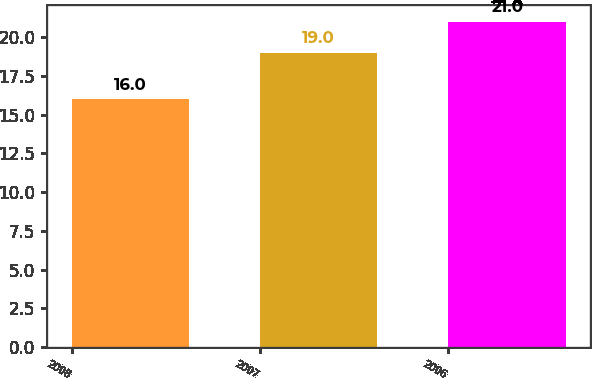<chart> <loc_0><loc_0><loc_500><loc_500><bar_chart><fcel>2008<fcel>2007<fcel>2006<nl><fcel>16<fcel>19<fcel>21<nl></chart> 